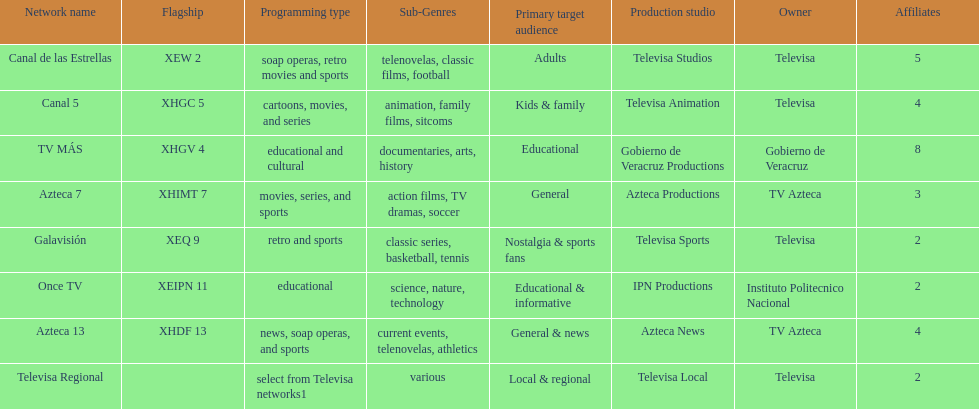How many networks have more affiliates than canal de las estrellas? 1. Could you parse the entire table? {'header': ['Network name', 'Flagship', 'Programming type', 'Sub-Genres', 'Primary target audience', 'Production studio', 'Owner', 'Affiliates'], 'rows': [['Canal de las Estrellas', 'XEW 2', 'soap operas, retro movies and sports', 'telenovelas, classic films, football', 'Adults', 'Televisa Studios', 'Televisa', '5'], ['Canal 5', 'XHGC 5', 'cartoons, movies, and series', 'animation, family films, sitcoms', 'Kids & family', 'Televisa Animation', 'Televisa', '4'], ['TV MÁS', 'XHGV 4', 'educational and cultural', 'documentaries, arts, history', 'Educational', 'Gobierno de Veracruz Productions', 'Gobierno de Veracruz', '8'], ['Azteca 7', 'XHIMT 7', 'movies, series, and sports', 'action films, TV dramas, soccer', 'General', 'Azteca Productions', 'TV Azteca', '3'], ['Galavisión', 'XEQ 9', 'retro and sports', 'classic series, basketball, tennis', 'Nostalgia & sports fans', 'Televisa Sports', 'Televisa', '2'], ['Once TV', 'XEIPN 11', 'educational', 'science, nature, technology', 'Educational & informative', 'IPN Productions', 'Instituto Politecnico Nacional', '2'], ['Azteca 13', 'XHDF 13', 'news, soap operas, and sports', 'current events, telenovelas, athletics', 'General & news', 'Azteca News', 'TV Azteca', '4'], ['Televisa Regional', '', 'select from Televisa networks1', 'various', 'Local & regional', 'Televisa Local', 'Televisa', '2']]} 